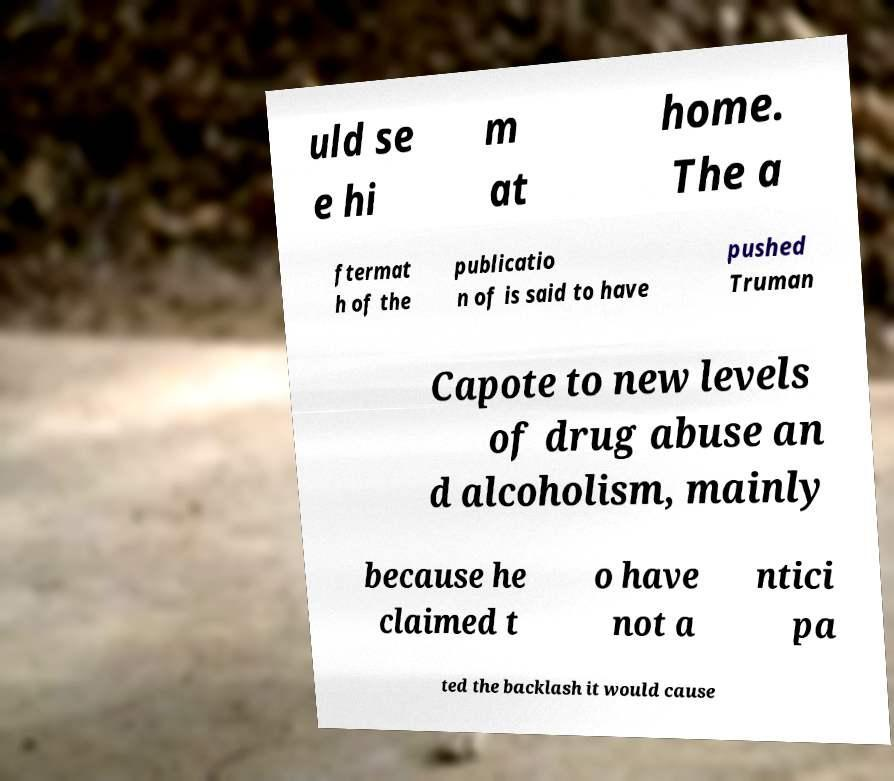Could you assist in decoding the text presented in this image and type it out clearly? uld se e hi m at home. The a ftermat h of the publicatio n of is said to have pushed Truman Capote to new levels of drug abuse an d alcoholism, mainly because he claimed t o have not a ntici pa ted the backlash it would cause 